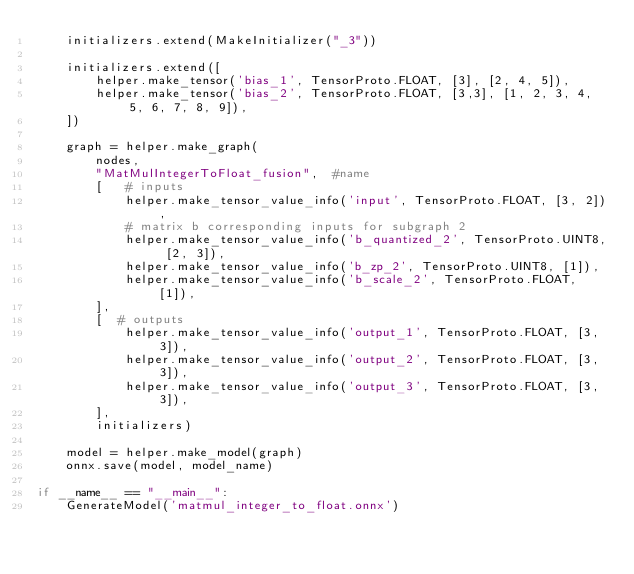<code> <loc_0><loc_0><loc_500><loc_500><_Python_>    initializers.extend(MakeInitializer("_3"))

    initializers.extend([
        helper.make_tensor('bias_1', TensorProto.FLOAT, [3], [2, 4, 5]),
        helper.make_tensor('bias_2', TensorProto.FLOAT, [3,3], [1, 2, 3, 4, 5, 6, 7, 8, 9]),
    ])

    graph = helper.make_graph(
        nodes,
        "MatMulIntegerToFloat_fusion",  #name
        [   # inputs
            helper.make_tensor_value_info('input', TensorProto.FLOAT, [3, 2]),
            # matrix b corresponding inputs for subgraph 2 
            helper.make_tensor_value_info('b_quantized_2', TensorProto.UINT8, [2, 3]),
            helper.make_tensor_value_info('b_zp_2', TensorProto.UINT8, [1]),
            helper.make_tensor_value_info('b_scale_2', TensorProto.FLOAT, [1]),
        ],
        [  # outputs
            helper.make_tensor_value_info('output_1', TensorProto.FLOAT, [3, 3]),
            helper.make_tensor_value_info('output_2', TensorProto.FLOAT, [3, 3]),
            helper.make_tensor_value_info('output_3', TensorProto.FLOAT, [3, 3]),
        ],
        initializers)

    model = helper.make_model(graph)
    onnx.save(model, model_name)

if __name__ == "__main__":
    GenerateModel('matmul_integer_to_float.onnx')</code> 